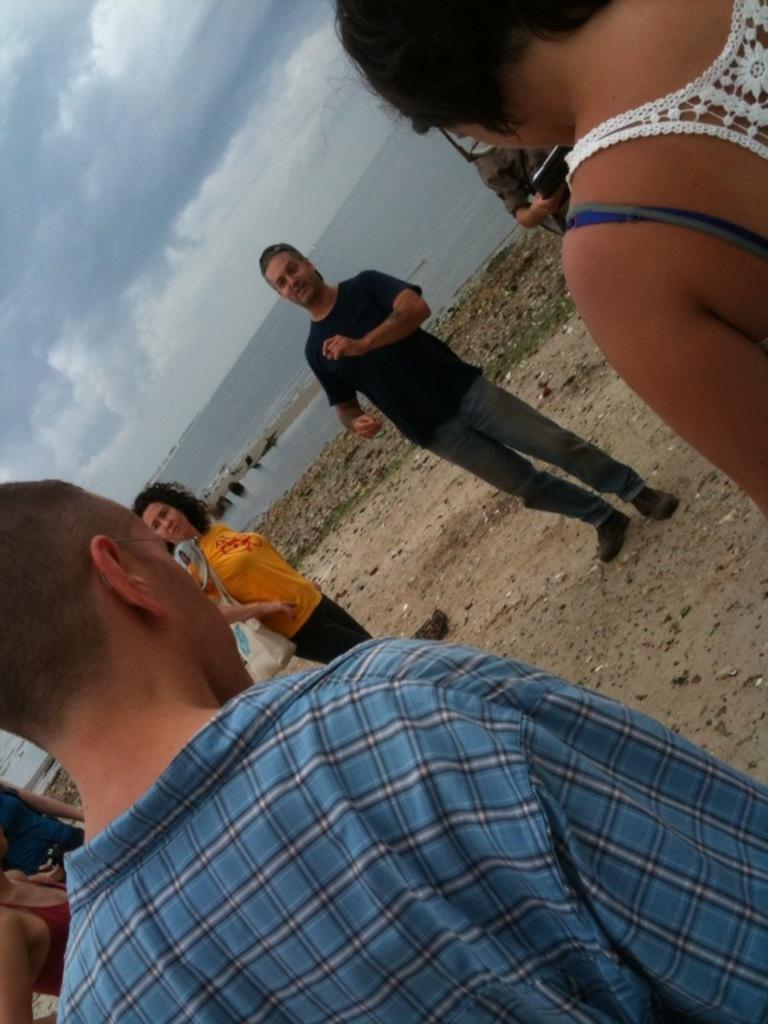What is happening in the image? There are people standing in the image. What can be seen in the background of the image? There is a river and the sky visible in the background of the image. What type of gold jewelry is being pushed on the wrist in the image? There is no gold jewelry or any pushing activity present in the image. 